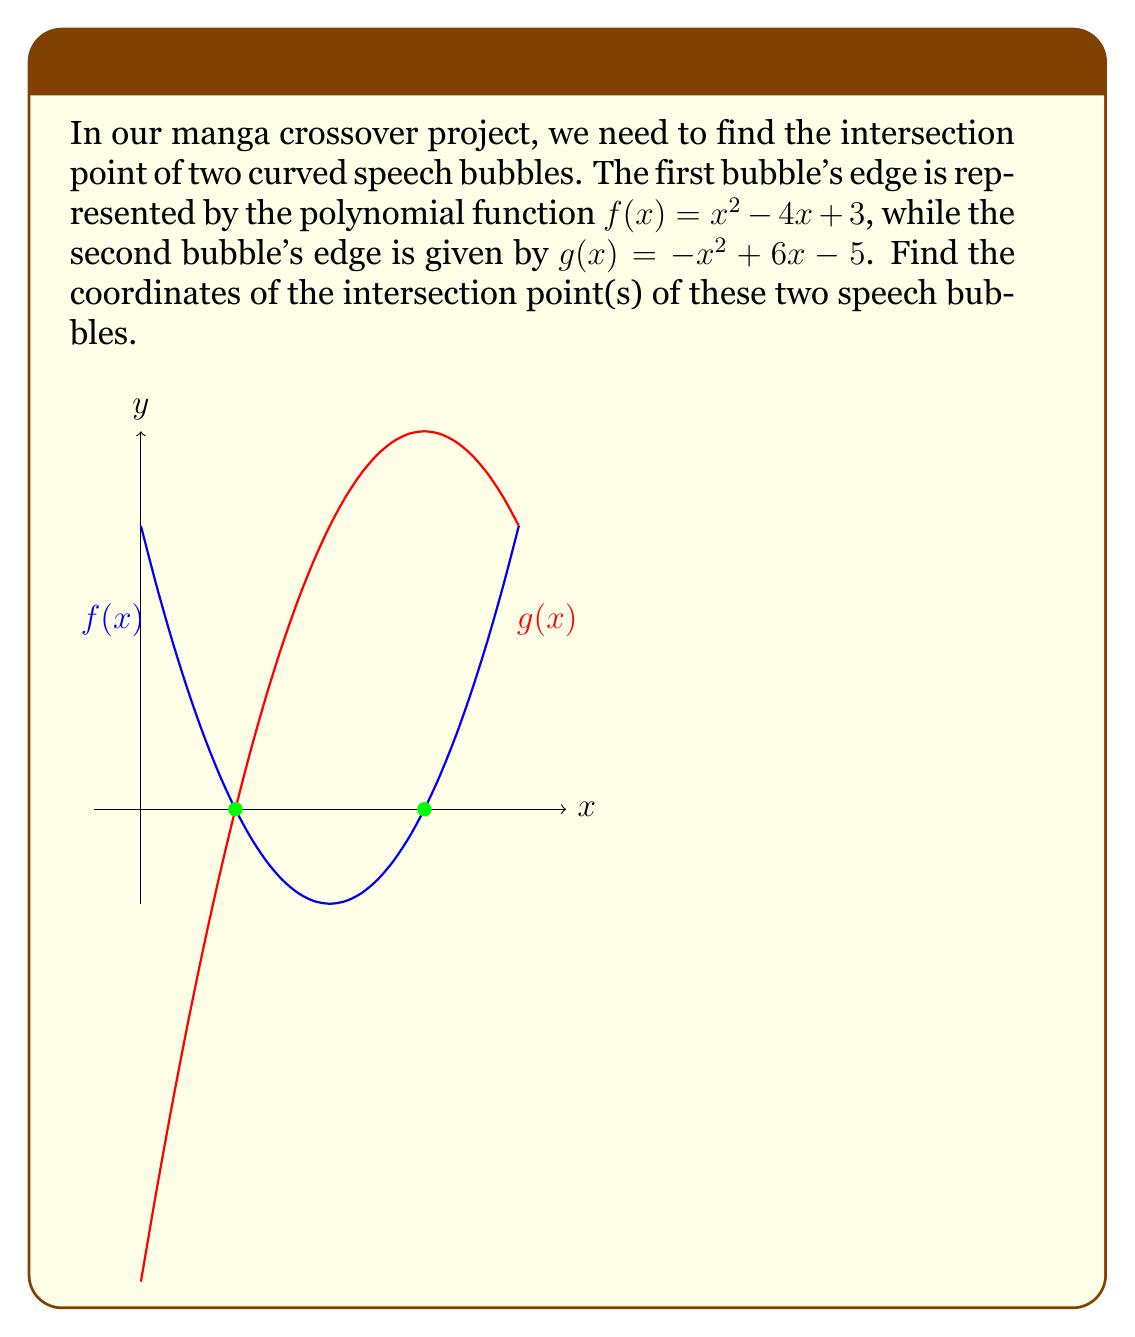Teach me how to tackle this problem. To find the intersection points, we need to solve the equation $f(x) = g(x)$:

1) Set up the equation:
   $x^2 - 4x + 3 = -x^2 + 6x - 5$

2) Rearrange all terms to one side:
   $2x^2 - 10x + 8 = 0$

3) This is a quadratic equation. We can solve it using the quadratic formula:
   $x = \frac{-b \pm \sqrt{b^2 - 4ac}}{2a}$
   where $a = 2$, $b = -10$, and $c = 8$

4) Substitute these values:
   $x = \frac{10 \pm \sqrt{(-10)^2 - 4(2)(8)}}{2(2)}$
   $= \frac{10 \pm \sqrt{100 - 64}}{4}$
   $= \frac{10 \pm \sqrt{36}}{4}$
   $= \frac{10 \pm 6}{4}$

5) This gives us two solutions:
   $x_1 = \frac{10 + 6}{4} = \frac{16}{4} = 4$
   $x_2 = \frac{10 - 6}{4} = \frac{4}{4} = 1$

6) To find the y-coordinates, we can substitute these x-values into either $f(x)$ or $g(x)$. Let's use $f(x)$:

   For $x_1 = 4$: $f(4) = 4^2 - 4(4) + 3 = 16 - 16 + 3 = 3$
   For $x_2 = 1$: $f(1) = 1^2 - 4(1) + 3 = 1 - 4 + 3 = 0$

Therefore, the intersection points are (1, 0) and (3, 0).
Answer: (1, 0) and (3, 0) 